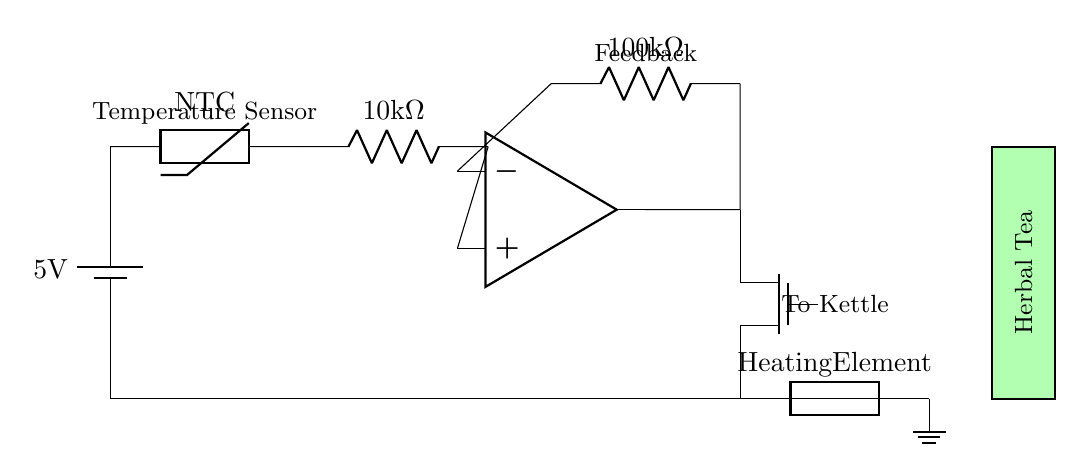What is the voltage of this circuit? The voltage is 5V, as indicated by the battery symbol in the circuit diagram.
Answer: 5V What component measures temperature? The temperature sensor in the circuit is represented by the thermistor, which is used to measure ambient temperature for precision brewing.
Answer: Thermistor What type of transistor is used in the circuit? The circuit includes an N-channel MOSFET, indicated by the notation 'Tnmos', which is used to control the heating element based on the output from the op-amp.
Answer: N-channel MOSFET What is the resistance value of the resistor connected to the thermistor? The resistor connected to the thermistor is marked as 10 kilohms, which helps in setting the correct operating point for the thermistor in the circuit.
Answer: 10 kilohms How does the op-amp function in this circuit? The op-amp compares the voltage from the thermistor with a reference voltage and adjusts the output to control the MOSFET, which regulates the power to the heating element based on the feedback received.
Answer: Comparator What is the purpose of the heating element in this circuit? The heating element's purpose is to provide controlled heat for brewing the herbal tea, ensuring precise temperature management during the infusion process.
Answer: Heating Element 